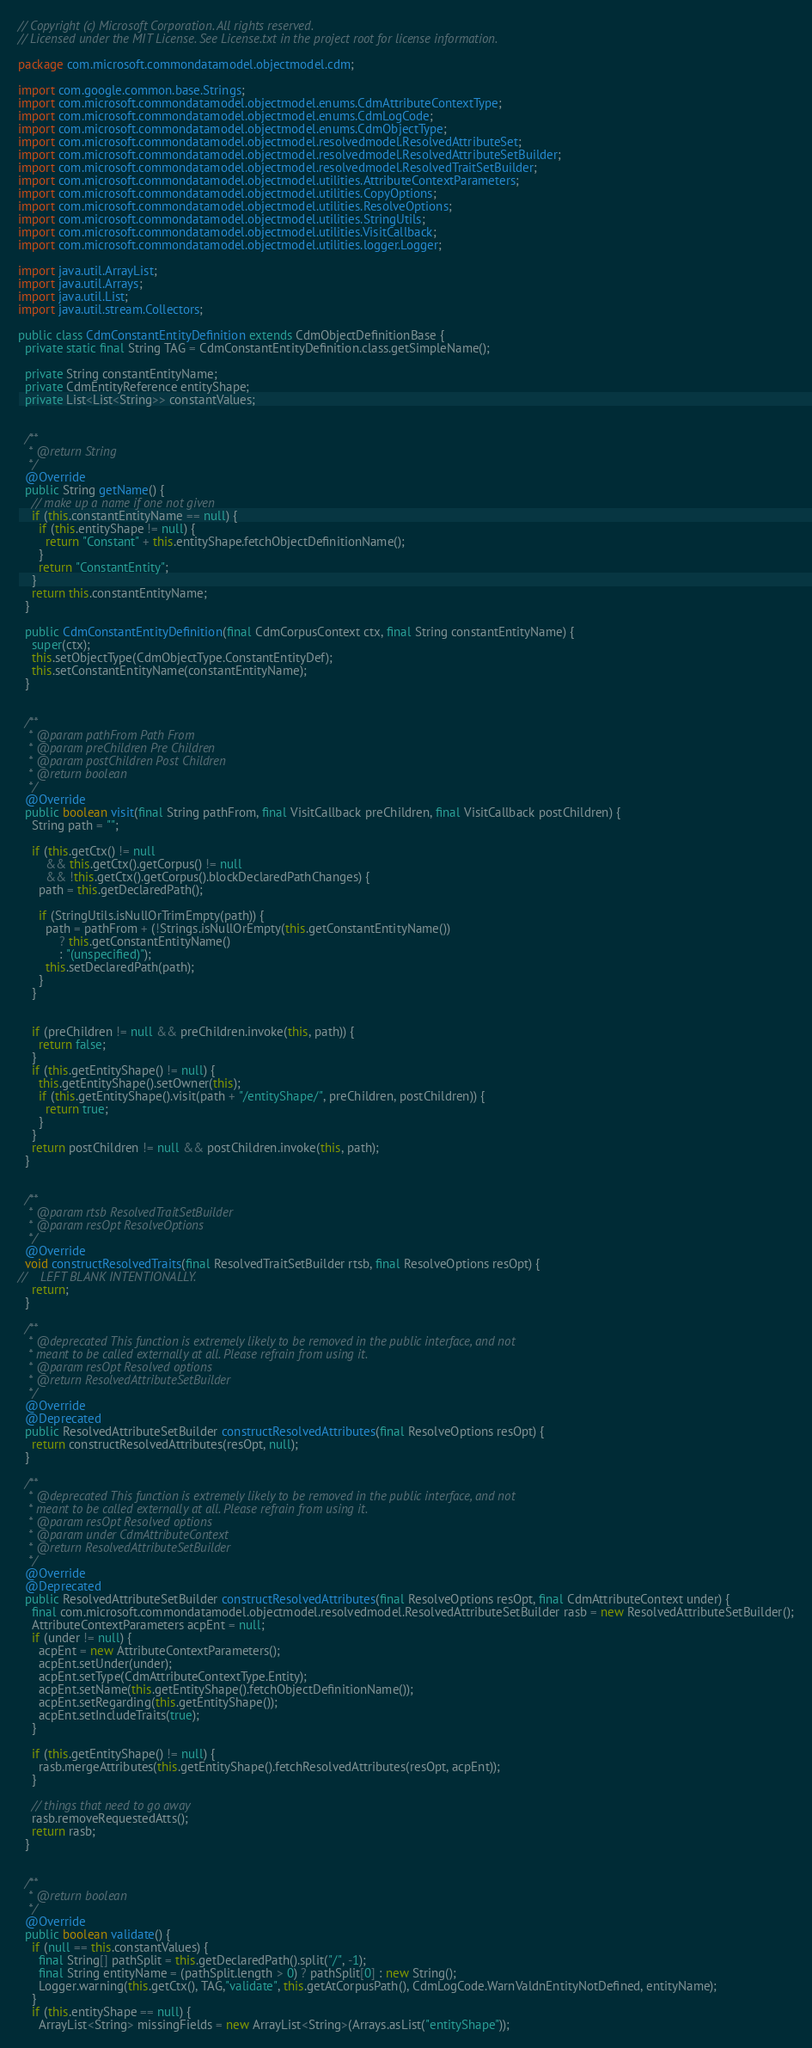<code> <loc_0><loc_0><loc_500><loc_500><_Java_>// Copyright (c) Microsoft Corporation. All rights reserved.
// Licensed under the MIT License. See License.txt in the project root for license information.

package com.microsoft.commondatamodel.objectmodel.cdm;

import com.google.common.base.Strings;
import com.microsoft.commondatamodel.objectmodel.enums.CdmAttributeContextType;
import com.microsoft.commondatamodel.objectmodel.enums.CdmLogCode;
import com.microsoft.commondatamodel.objectmodel.enums.CdmObjectType;
import com.microsoft.commondatamodel.objectmodel.resolvedmodel.ResolvedAttributeSet;
import com.microsoft.commondatamodel.objectmodel.resolvedmodel.ResolvedAttributeSetBuilder;
import com.microsoft.commondatamodel.objectmodel.resolvedmodel.ResolvedTraitSetBuilder;
import com.microsoft.commondatamodel.objectmodel.utilities.AttributeContextParameters;
import com.microsoft.commondatamodel.objectmodel.utilities.CopyOptions;
import com.microsoft.commondatamodel.objectmodel.utilities.ResolveOptions;
import com.microsoft.commondatamodel.objectmodel.utilities.StringUtils;
import com.microsoft.commondatamodel.objectmodel.utilities.VisitCallback;
import com.microsoft.commondatamodel.objectmodel.utilities.logger.Logger;

import java.util.ArrayList;
import java.util.Arrays;
import java.util.List;
import java.util.stream.Collectors;

public class CdmConstantEntityDefinition extends CdmObjectDefinitionBase {
  private static final String TAG = CdmConstantEntityDefinition.class.getSimpleName();

  private String constantEntityName;
  private CdmEntityReference entityShape;
  private List<List<String>> constantValues;

  
  /** 
   * @return String
   */
  @Override
  public String getName() {
    // make up a name if one not given
    if (this.constantEntityName == null) {
      if (this.entityShape != null) {
        return "Constant" + this.entityShape.fetchObjectDefinitionName();
      }
      return "ConstantEntity";
    }
    return this.constantEntityName;
  }

  public CdmConstantEntityDefinition(final CdmCorpusContext ctx, final String constantEntityName) {
    super(ctx);
    this.setObjectType(CdmObjectType.ConstantEntityDef);
    this.setConstantEntityName(constantEntityName);
  }

  
  /** 
   * @param pathFrom Path From
   * @param preChildren Pre Children
   * @param postChildren Post Children
   * @return boolean
   */
  @Override
  public boolean visit(final String pathFrom, final VisitCallback preChildren, final VisitCallback postChildren) {
    String path = "";

    if (this.getCtx() != null
        && this.getCtx().getCorpus() != null
        && !this.getCtx().getCorpus().blockDeclaredPathChanges) {
      path = this.getDeclaredPath();

      if (StringUtils.isNullOrTrimEmpty(path)) {
        path = pathFrom + (!Strings.isNullOrEmpty(this.getConstantEntityName())
            ? this.getConstantEntityName()
            : "(unspecified)");
        this.setDeclaredPath(path);
      }
    }


    if (preChildren != null && preChildren.invoke(this, path)) {
      return false;
    }
    if (this.getEntityShape() != null) {
      this.getEntityShape().setOwner(this);
      if (this.getEntityShape().visit(path + "/entityShape/", preChildren, postChildren)) {
        return true;
      }
    }
    return postChildren != null && postChildren.invoke(this, path);
  }

  
  /** 
   * @param rtsb ResolvedTraitSetBuilder
   * @param resOpt ResolveOptions
   */
  @Override
  void constructResolvedTraits(final ResolvedTraitSetBuilder rtsb, final ResolveOptions resOpt) {
//    LEFT BLANK INTENTIONALLY.
    return;
  }

  /**
   * @deprecated This function is extremely likely to be removed in the public interface, and not
   * meant to be called externally at all. Please refrain from using it.
   * @param resOpt Resolved options
   * @return ResolvedAttributeSetBuilder
   */
  @Override
  @Deprecated
  public ResolvedAttributeSetBuilder constructResolvedAttributes(final ResolveOptions resOpt) {
    return constructResolvedAttributes(resOpt, null);
  }

  /**
   * @deprecated This function is extremely likely to be removed in the public interface, and not
   * meant to be called externally at all. Please refrain from using it.
   * @param resOpt Resolved options
   * @param under CdmAttributeContext
   * @return ResolvedAttributeSetBuilder
   */
  @Override
  @Deprecated
  public ResolvedAttributeSetBuilder constructResolvedAttributes(final ResolveOptions resOpt, final CdmAttributeContext under) {
    final com.microsoft.commondatamodel.objectmodel.resolvedmodel.ResolvedAttributeSetBuilder rasb = new ResolvedAttributeSetBuilder();
    AttributeContextParameters acpEnt = null;
    if (under != null) {
      acpEnt = new AttributeContextParameters();
      acpEnt.setUnder(under);
      acpEnt.setType(CdmAttributeContextType.Entity);
      acpEnt.setName(this.getEntityShape().fetchObjectDefinitionName());
      acpEnt.setRegarding(this.getEntityShape());
      acpEnt.setIncludeTraits(true);
    }

    if (this.getEntityShape() != null) {
      rasb.mergeAttributes(this.getEntityShape().fetchResolvedAttributes(resOpt, acpEnt));
    }

    // things that need to go away
    rasb.removeRequestedAtts();
    return rasb;
  }

  
  /** 
   * @return boolean
   */
  @Override
  public boolean validate() {
    if (null == this.constantValues) {
      final String[] pathSplit = this.getDeclaredPath().split("/", -1);
      final String entityName = (pathSplit.length > 0) ? pathSplit[0] : new String();
      Logger.warning(this.getCtx(), TAG,"validate", this.getAtCorpusPath(), CdmLogCode.WarnValdnEntityNotDefined, entityName);
    }
    if (this.entityShape == null) {
      ArrayList<String> missingFields = new ArrayList<String>(Arrays.asList("entityShape"));</code> 